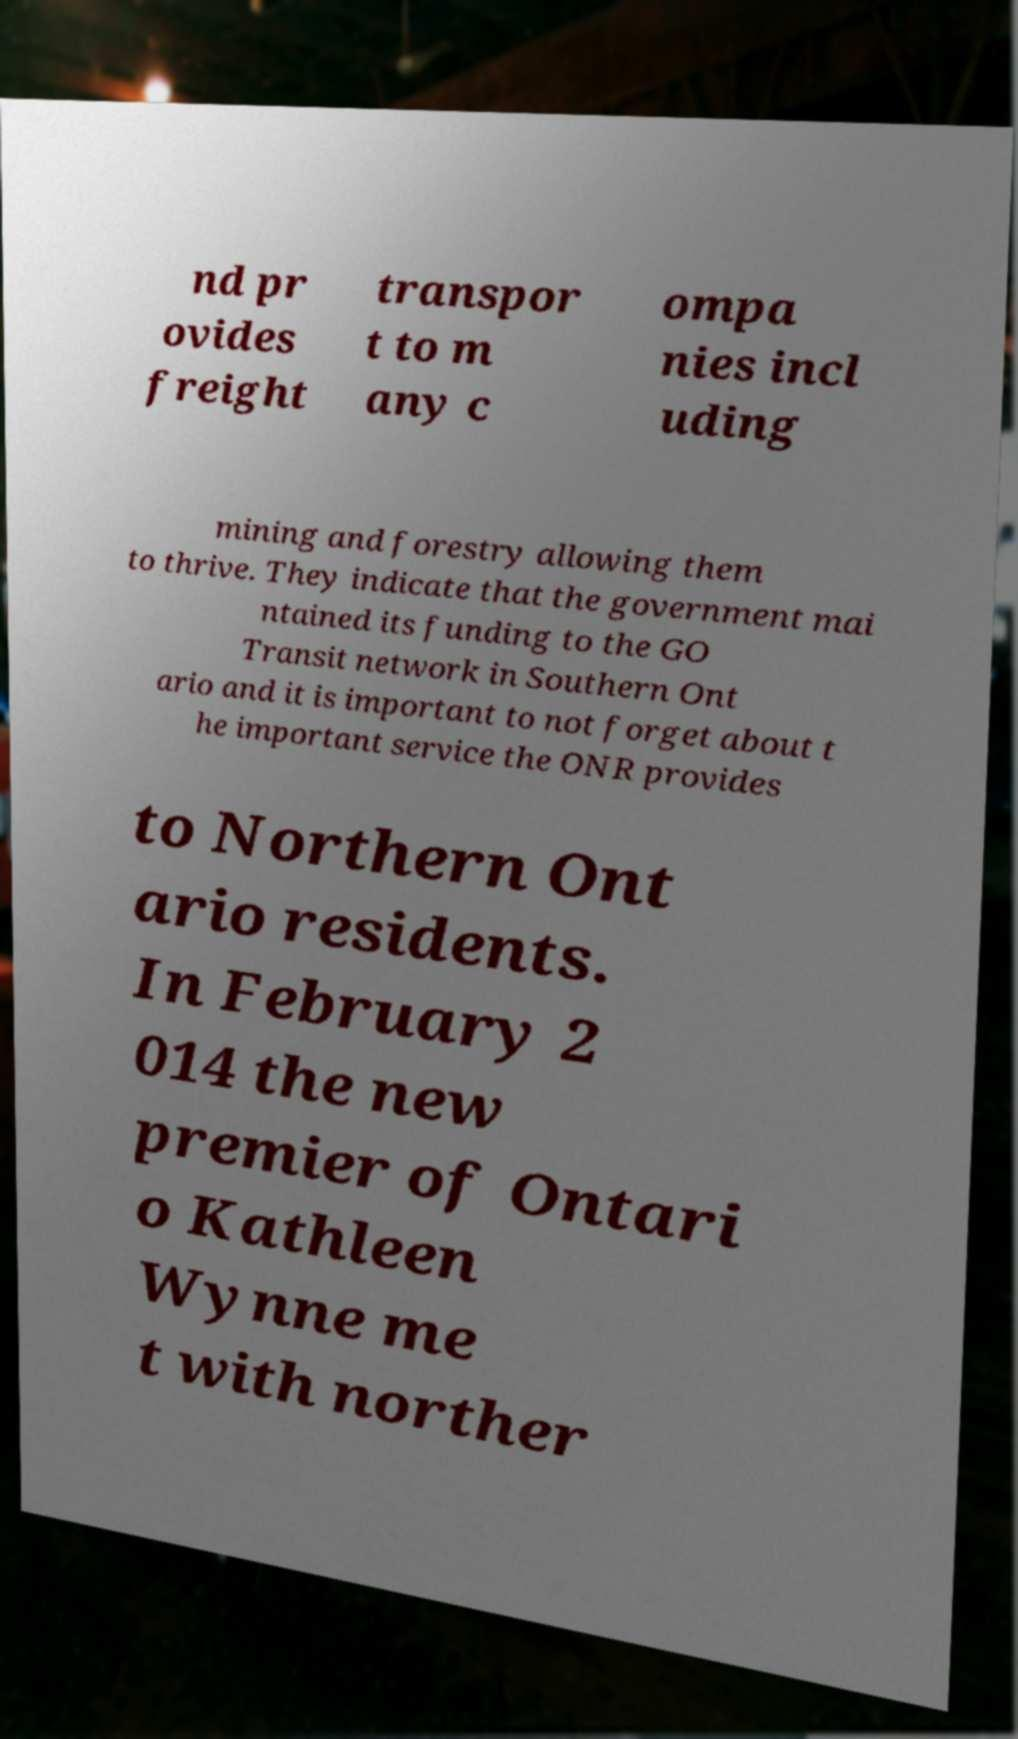Please read and relay the text visible in this image. What does it say? nd pr ovides freight transpor t to m any c ompa nies incl uding mining and forestry allowing them to thrive. They indicate that the government mai ntained its funding to the GO Transit network in Southern Ont ario and it is important to not forget about t he important service the ONR provides to Northern Ont ario residents. In February 2 014 the new premier of Ontari o Kathleen Wynne me t with norther 